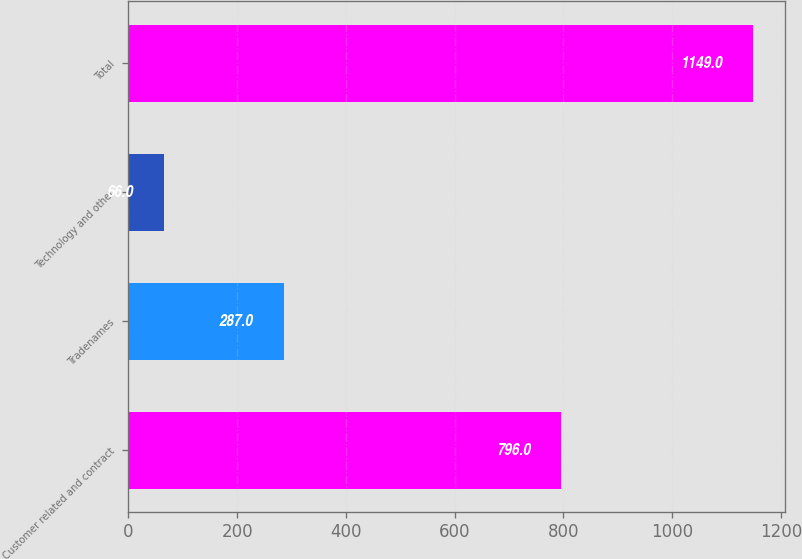<chart> <loc_0><loc_0><loc_500><loc_500><bar_chart><fcel>Customer related and contract<fcel>Tradenames<fcel>Technology and other<fcel>Total<nl><fcel>796<fcel>287<fcel>66<fcel>1149<nl></chart> 